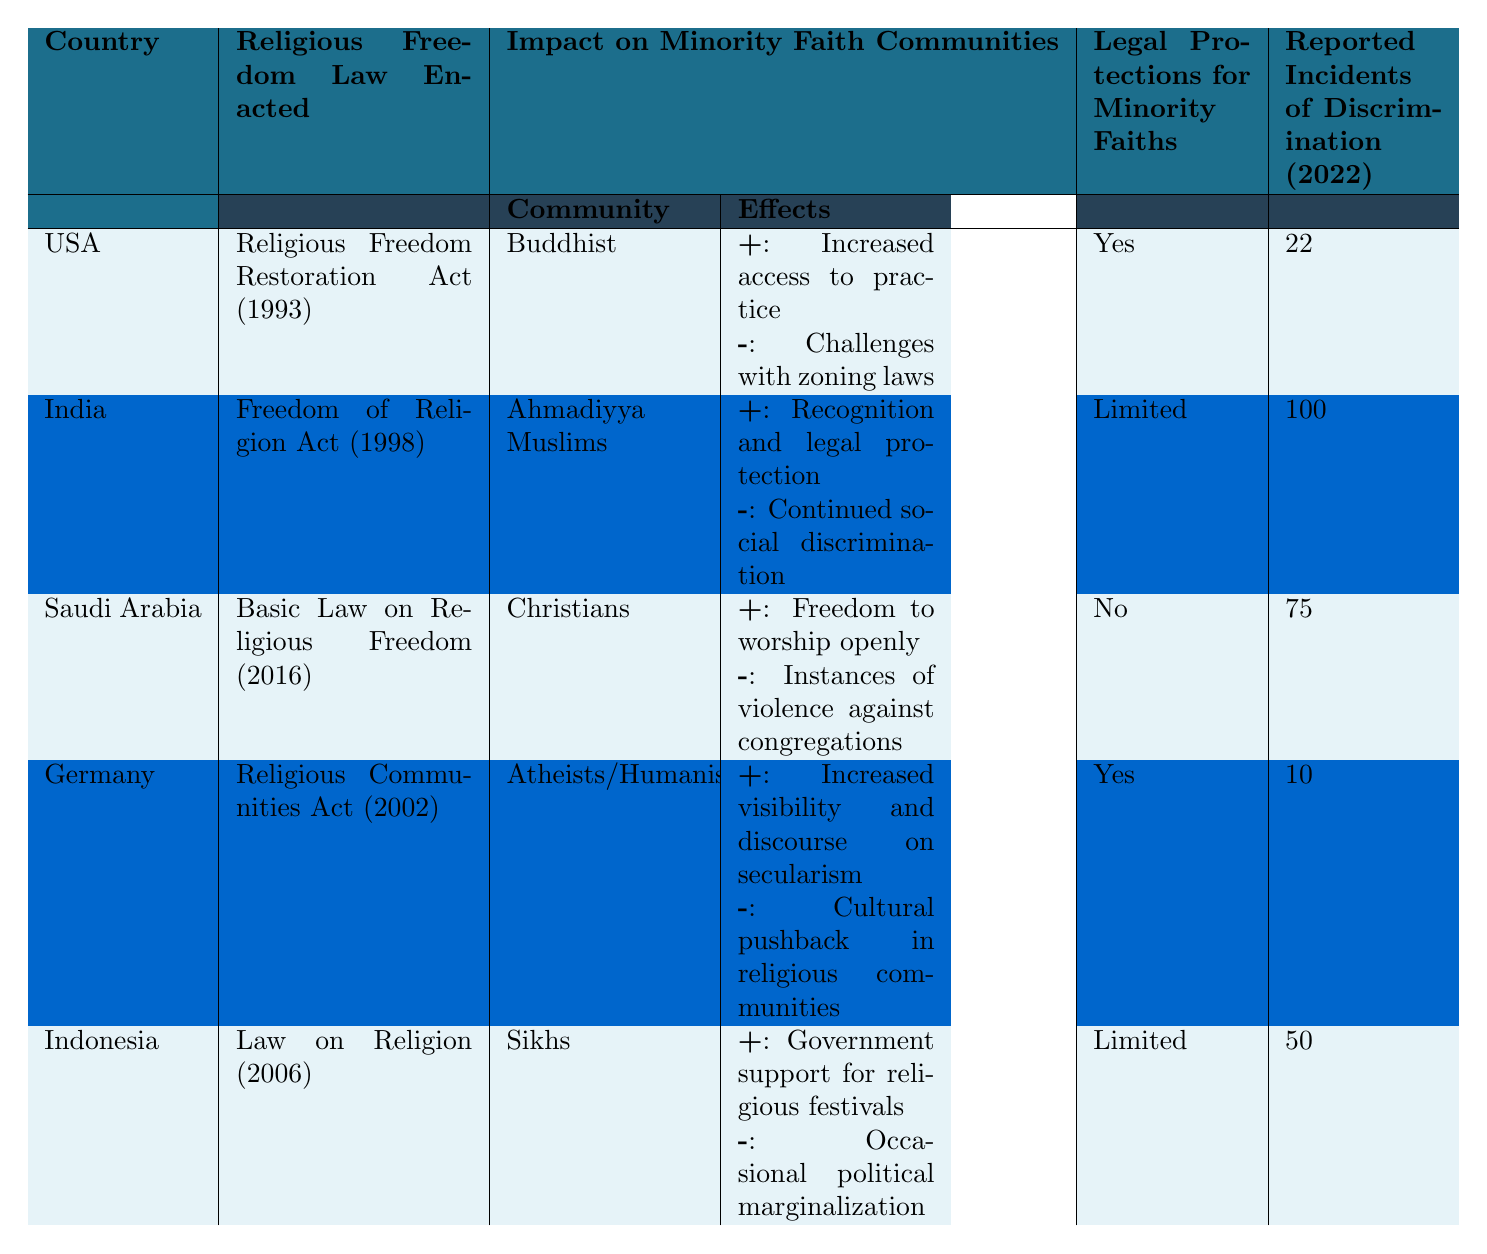What religious freedom law was enacted in the USA? The table shows that the USA enacted the "Religious Freedom Restoration Act" in 1993.
Answer: Religious Freedom Restoration Act (1993) How many reported incidents of discrimination were there in India in 2022? Referencing the table, India had 100 reported incidents of discrimination in 2022.
Answer: 100 Which country has legal protections for minority faiths listed as "No"? Saudi Arabia is the only country listed with "No" legal protections for minority faiths in the table.
Answer: Saudi Arabia What are the positive effects for Buddhists in the USA? The table indicates that Buddhists in the USA have increased access to practice, which is listed under positive effects.
Answer: Increased access to practice How many countries provided limited legal protections for minority faiths? By checking the table, India and Indonesia both have limited legal protections for minority faiths, which totals to two countries.
Answer: 2 What is the average number of reported incidents of discrimination across all five countries? The incidents of discrimination are 22, 100, 75, 10, and 50. Adding these gives a total of 257 incidents. Dividing by 5 countries results in an average of 257/5 = 51.4.
Answer: 51.4 Which minority community in Germany experienced negative effects? The table shows that Atheists/Humanists in Germany faced cultural pushback in religious communities, which is listed as a negative effect.
Answer: Atheists/Humanists In which country do Ahmadiyya Muslims have legal protections that are limited? The table indicates that Ahmadiyya Muslims in India, which has limited legal protections, are part of this category.
Answer: India What is the difference in reported incidents of discrimination between USA and Saudi Arabia? The USA has 22 incidents and Saudi Arabia has 75 incidents. The difference is 75 - 22 = 53.
Answer: 53 Which community has the most reported incidents of discrimination based on the 2022 data? Based on the table, Ahmadiyya Muslims in India faced the most reported incidents, with 100 incidents in 2022.
Answer: Ahmadiyya Muslims 